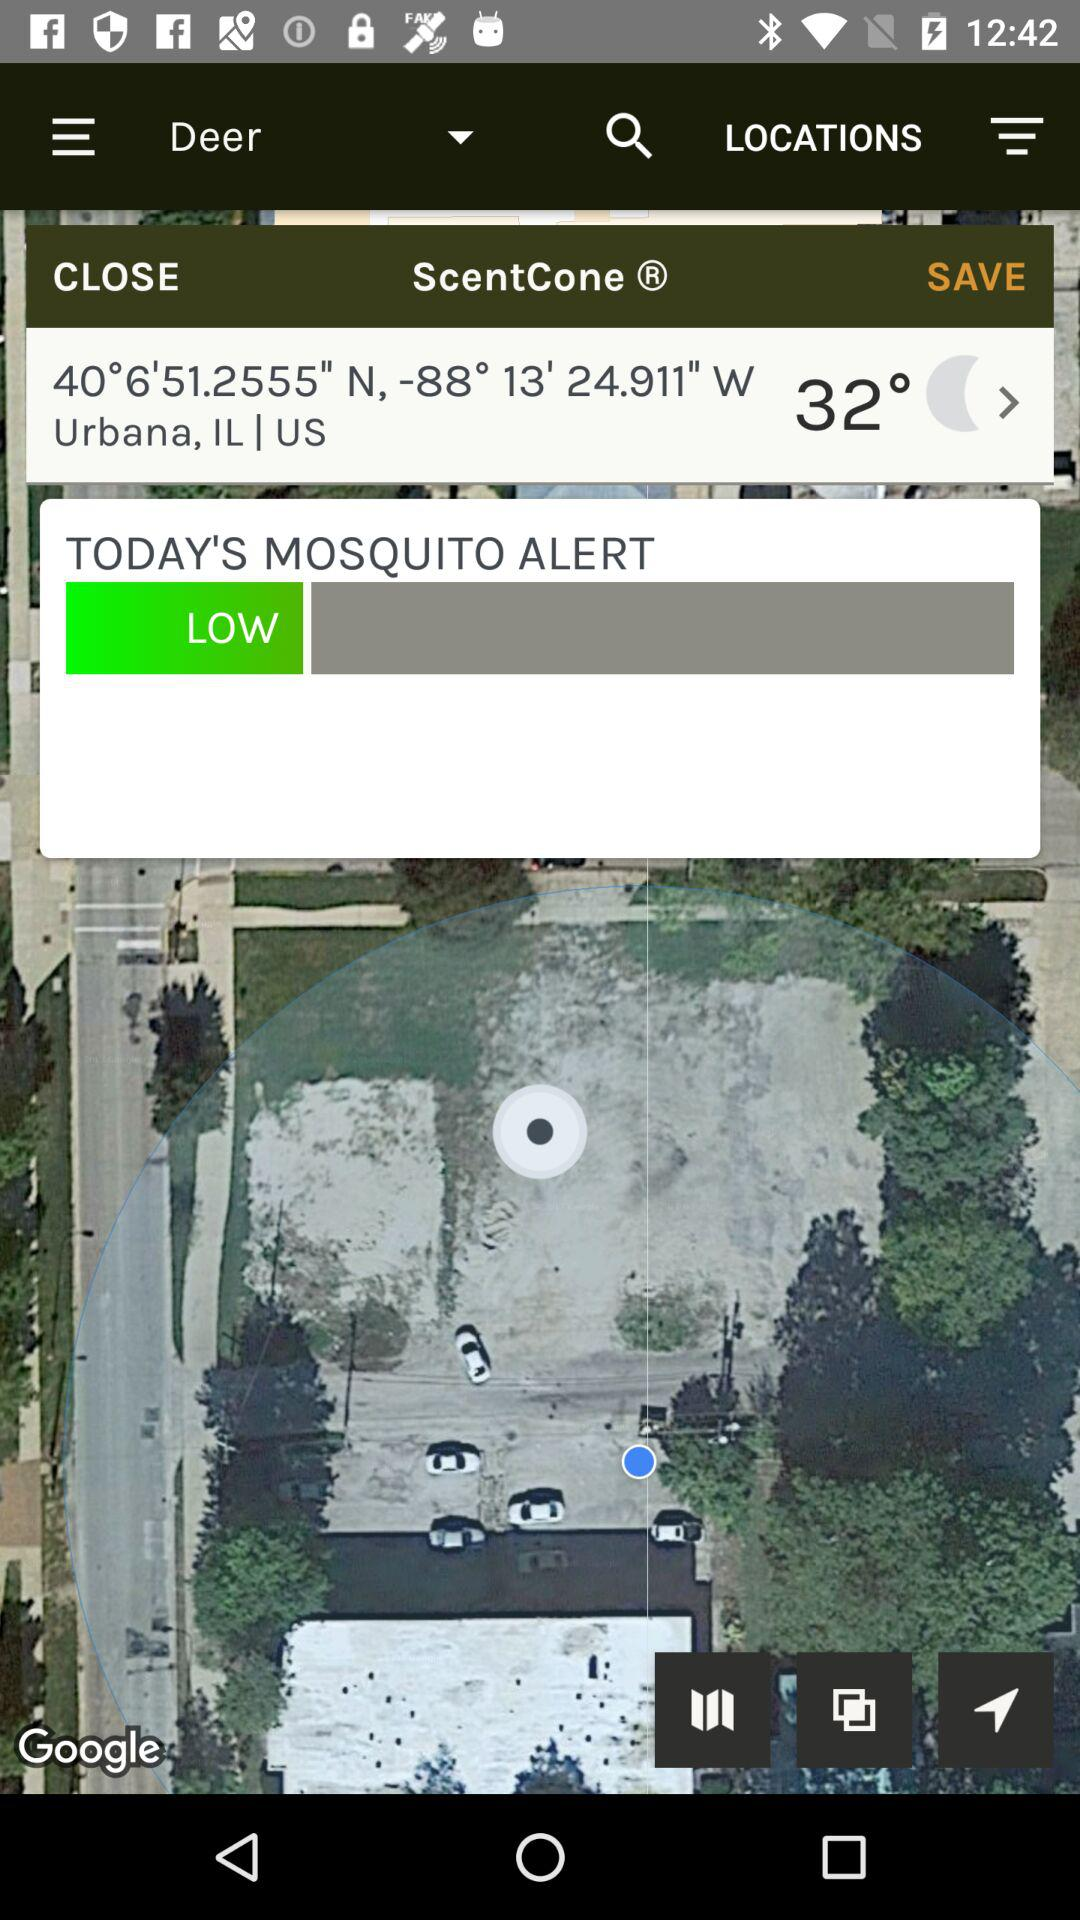What is the longitude of Urbana? The longitude of Urbana is -88° 13' 24.911" W. 